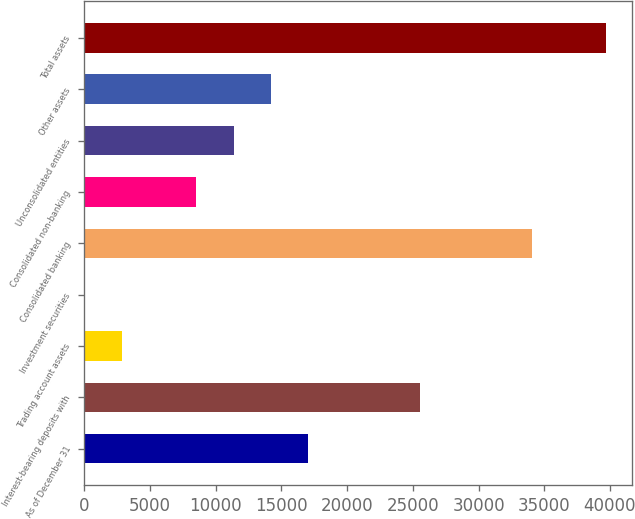<chart> <loc_0><loc_0><loc_500><loc_500><bar_chart><fcel>As of December 31<fcel>Interest-bearing deposits with<fcel>Trading account assets<fcel>Investment securities<fcel>Consolidated banking<fcel>Consolidated non-banking<fcel>Unconsolidated entities<fcel>Other assets<fcel>Total assets<nl><fcel>17038.6<fcel>25545.4<fcel>2860.6<fcel>25<fcel>34052.2<fcel>8531.8<fcel>11367.4<fcel>14203<fcel>39723.4<nl></chart> 